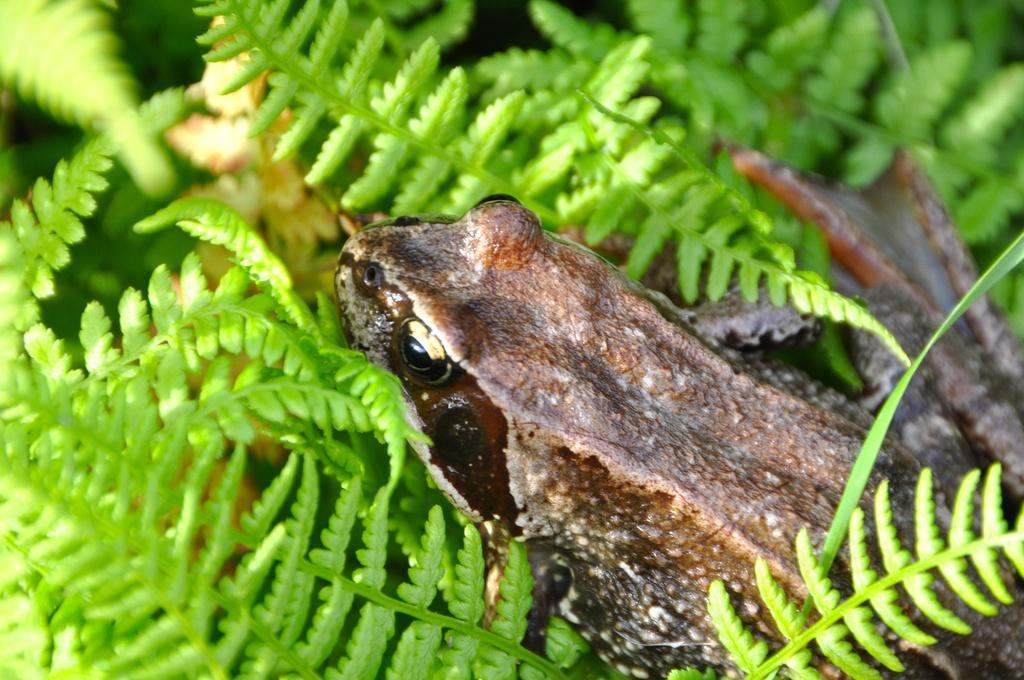In one or two sentences, can you explain what this image depicts? In this picture we can see a frog and in the background we can see leaves. 